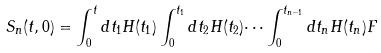Convert formula to latex. <formula><loc_0><loc_0><loc_500><loc_500>S _ { n } ( t , 0 ) = \int _ { 0 } ^ { t } d t _ { 1 } H ( t _ { 1 } ) \int _ { 0 } ^ { t _ { 1 } } d t _ { 2 } H ( t _ { 2 } ) \dots \int _ { 0 } ^ { t _ { n - 1 } } d t _ { n } H ( t _ { n } ) F</formula> 